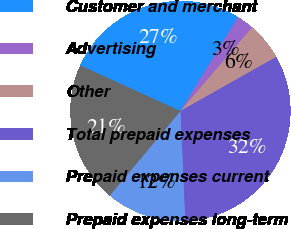<chart> <loc_0><loc_0><loc_500><loc_500><pie_chart><fcel>Customer and merchant<fcel>Advertising<fcel>Other<fcel>Total prepaid expenses<fcel>Prepaid expenses current<fcel>Prepaid expenses long-term<nl><fcel>26.96%<fcel>2.53%<fcel>5.53%<fcel>32.49%<fcel>11.77%<fcel>20.72%<nl></chart> 